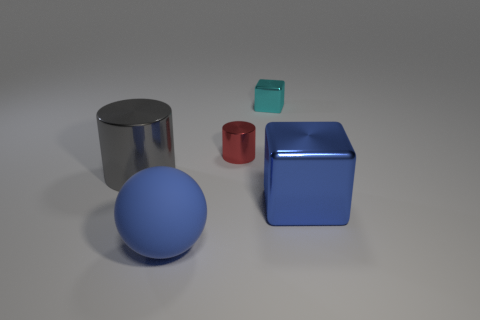Could you tell me what time of day it may be, based on the lighting in the scene? The lighting in the image appears to be uniform and soft, likely indicative of a controlled indoor environment with artificial lighting. There aren't any cues such as shadows or sunlight that would suggest a particular time of day in an outdoor setting. 